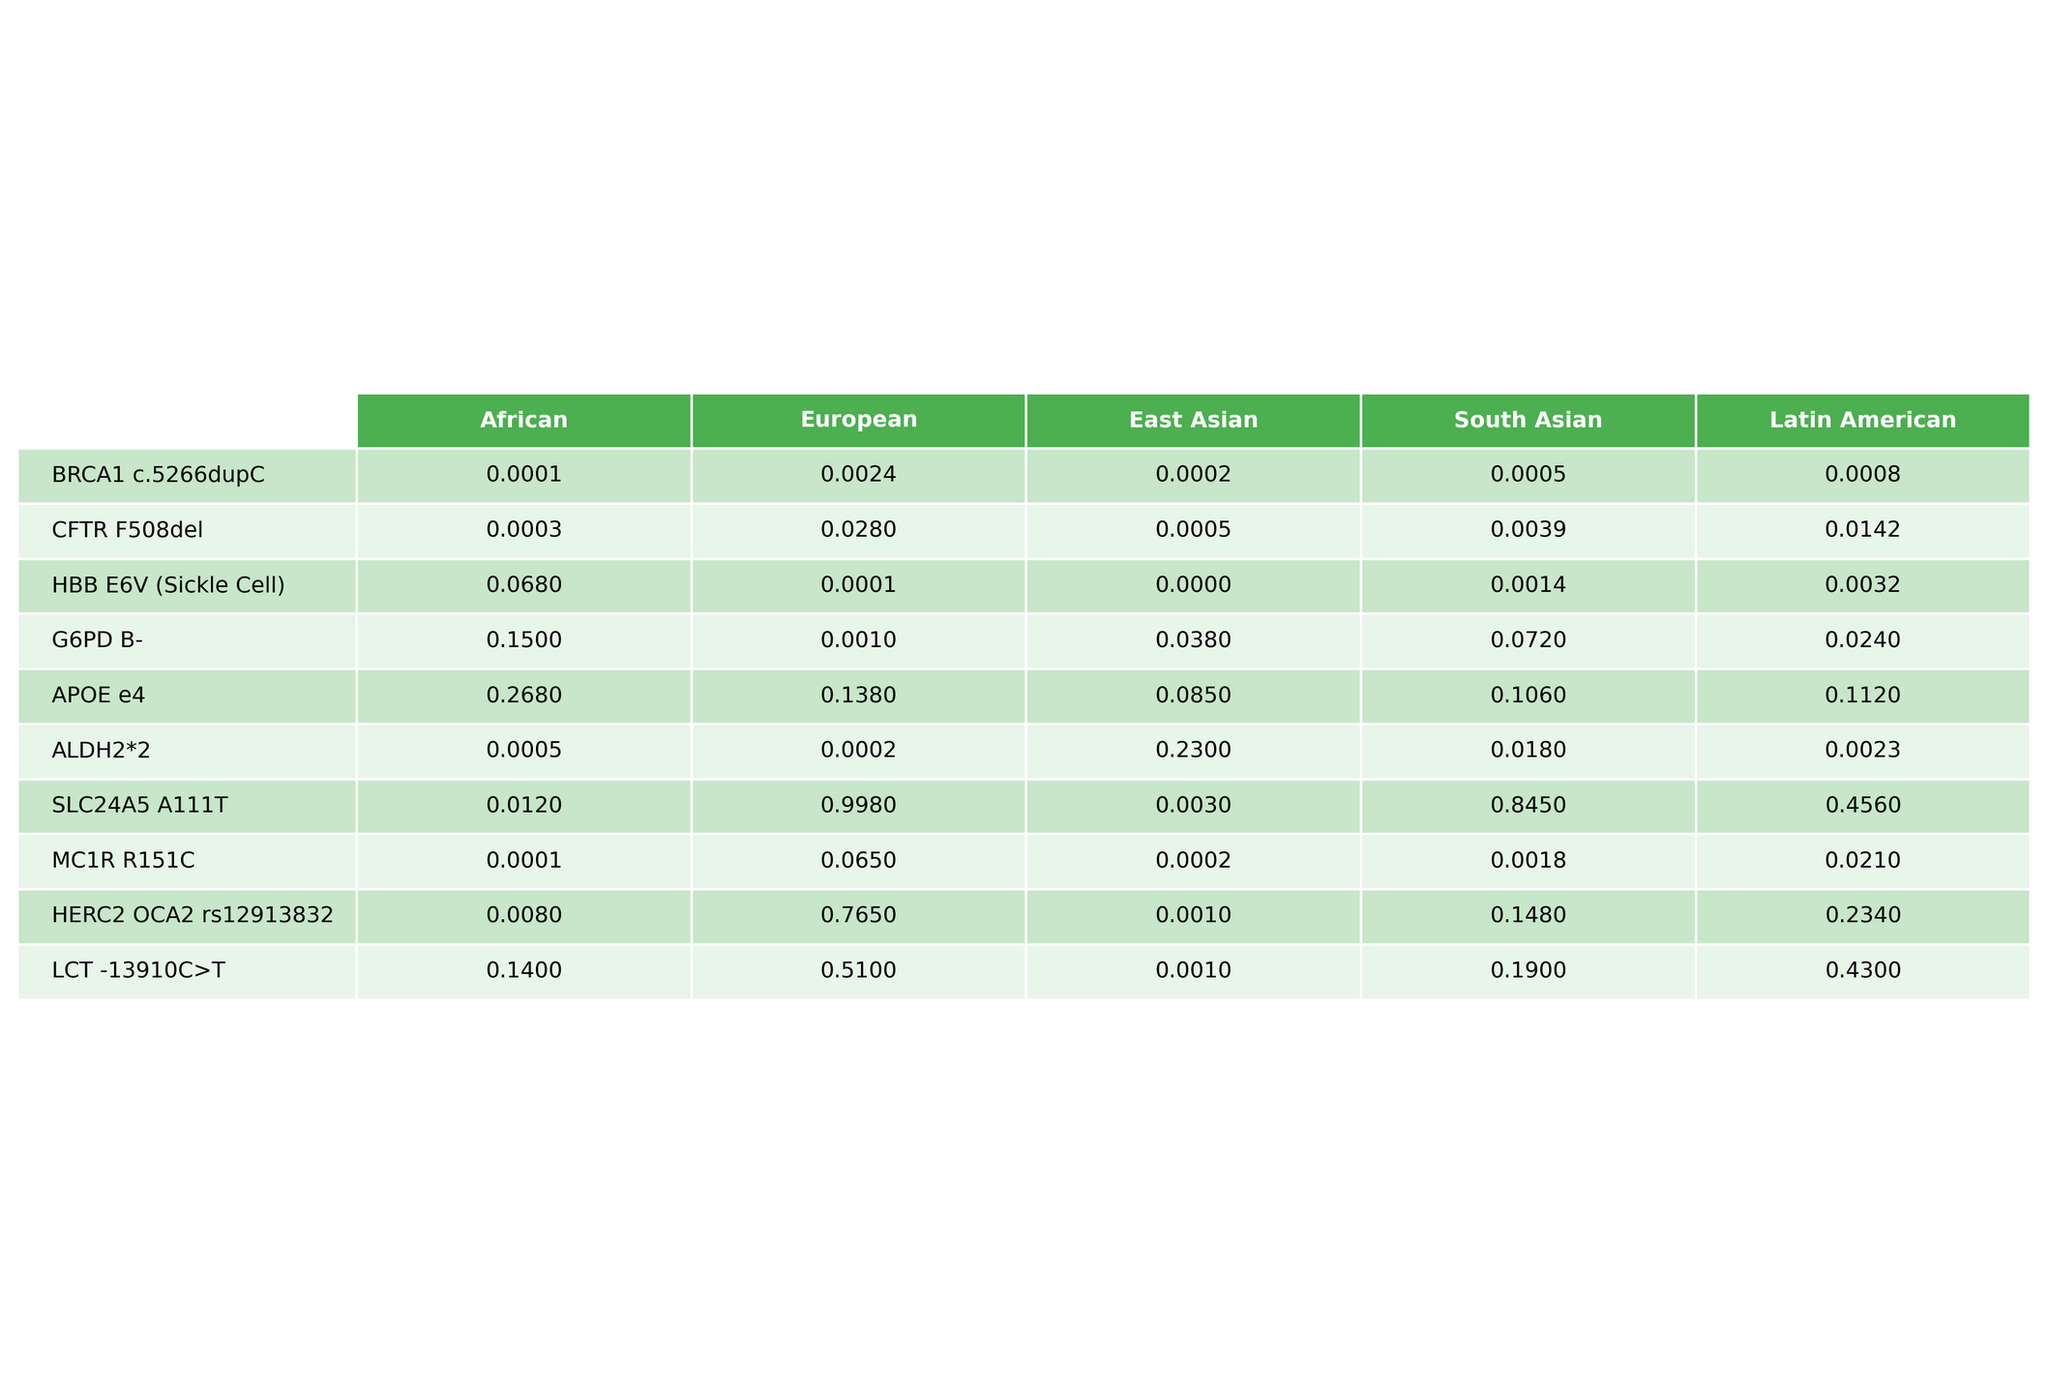What is the occurrence rate of the BRCA1 c.5266dupC variant in East Asian populations? The table shows the occurrence rates for different variants across various populations. For the BRCA1 c.5266dupC variant, the East Asian occurrence rate is listed as 0.0002.
Answer: 0.0002 Which variant has the highest occurrence rate in the European population? By comparing the values in the European column for all variants, the CFTR F508del variant has the highest occurrence rate at 0.0280.
Answer: CFTR F508del What is the average occurrence rate of the HBB E6V variant across all populations? The rates for the HBB E6V variant are 0.0680 (African), 0.0001 (European), 0.0000 (East Asian), 0.0014 (South Asian), and 0.0032 (Latin American). Summing these values gives 0.0727, and dividing by 5 provides an average of 0.01454.
Answer: 0.0145 Is the occurrence rate of the G6PD B- variant higher in Latin American populations than in South Asian populations? The G6PD B- variant occurrence rates are 0.0240 (Latin American) and 0.0720 (South Asian). Since 0.0240 is less than 0.0720, the occurrence rate in Latin American populations is not higher.
Answer: No What is the difference in the occurrence rates of APOE e4 between African and European populations? The occurrence rate of APOE e4 in African populations is 0.2680, while in European populations it is 0.1380. Computing the difference gives 0.2680 - 0.1380 = 0.1300.
Answer: 0.1300 Which two variants have the highest combined occurrence rates in South Asian populations? Looking at the South Asian column, the variants and their rates are HBB E6V (0.0014) and G6PD B- (0.0720), which sum to 0.0734. For a better total, we realize the highest two variants are LCT -13910C>T (0.1900) and G6PD B- (0.0720) with a total of 0.2620.
Answer: LCT -13910C>T and G6PD B- Is it true that the ALDH2*2 variant has a higher occurrence rate in East Asian populations compared to the European populations? The occurrence rates for ALDH2*2 are 0.2300 (East Asian) and 0.0002 (European). Since 0.2300 is greater than 0.0002, this statement is true.
Answer: Yes What is the total occurrence rate of SLC24A5 A111T variant across the African, South Asian, and Latin American populations? The rates for SLC24A5 A111T are 0.0120 (African), 0.8450 (South Asian), and 0.4560 (Latin American). Adding these gives 0.0120 + 0.8450 + 0.4560 = 1.3130.
Answer: 1.3130 Which population has the lowest occurrence rate for the CFTR F508del variant? The CFTR F508del variant occurrence rates are 0.0003 (African), 0.0280 (European), 0.0005 (East Asian), 0.0039 (South Asian), and 0.0142 (Latin American). The rate in the African population is the lowest.
Answer: African population What is the occurrence rate of the HERC2 OCA2 rs12913832 variant in the European population, and how does it compare to the rate in the African population? The occurrence rate for HERC2 OCA2 rs12913832 in the European population is 0.7650, and in the African population, it is 0.0080. Since 0.7650 is significantly higher than 0.0080, the European population has a much higher rate.
Answer: Significantly higher 